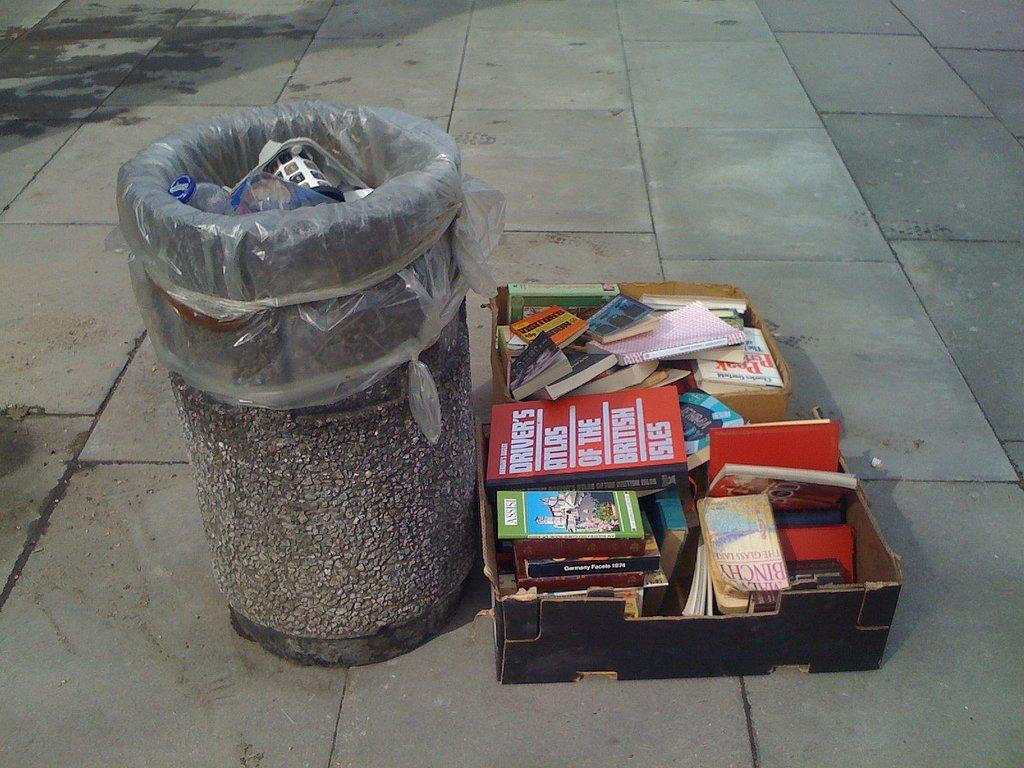<image>
Describe the image concisely. a trash bin withe a pile of books near it, one says DRIVER'S ATLAS OF THE BRITISH on it. 